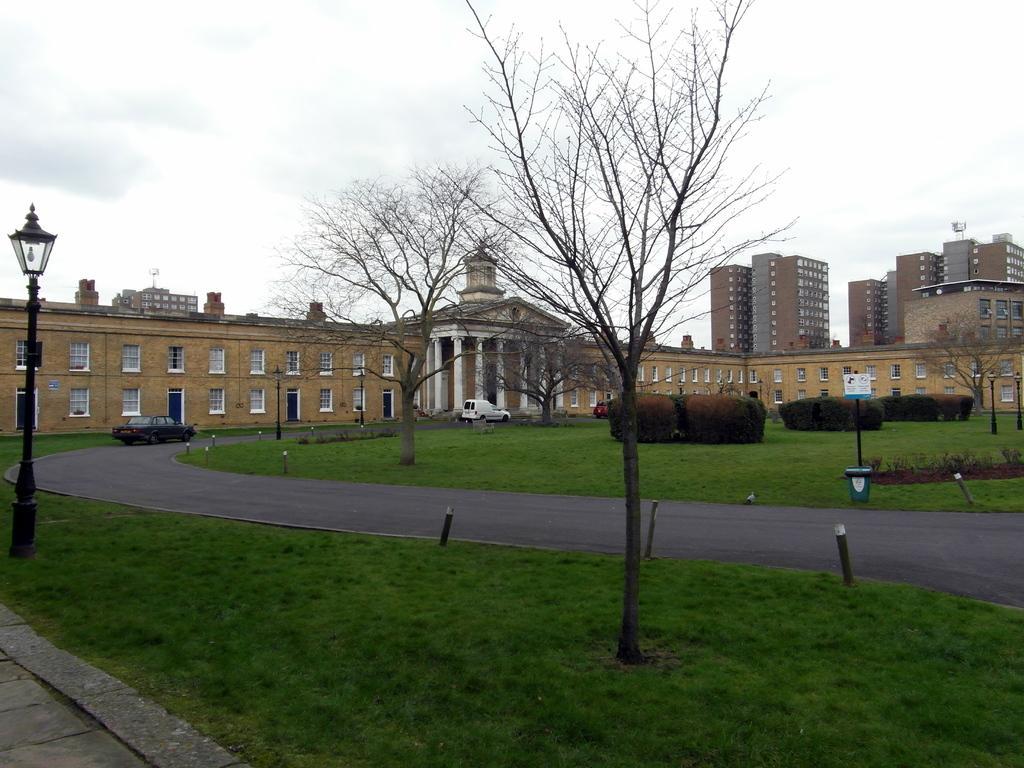Please provide a concise description of this image. In this picture we can see grass, few trees, poles and lights, on the right side of the image we can see a dustbin and a sign board, in the background we can find few vehicles, buildings and clouds. 